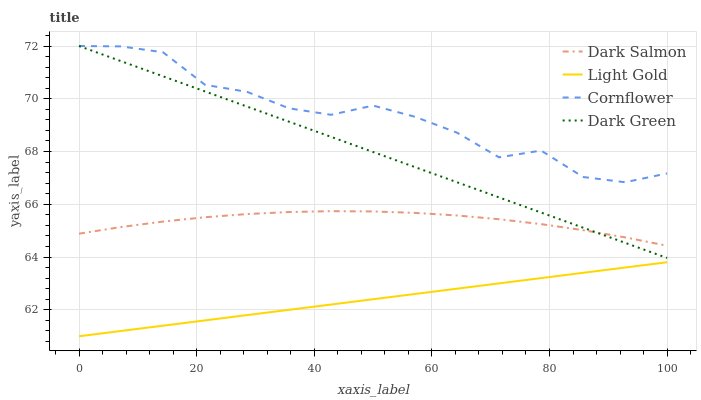Does Light Gold have the minimum area under the curve?
Answer yes or no. Yes. Does Cornflower have the maximum area under the curve?
Answer yes or no. Yes. Does Dark Salmon have the minimum area under the curve?
Answer yes or no. No. Does Dark Salmon have the maximum area under the curve?
Answer yes or no. No. Is Light Gold the smoothest?
Answer yes or no. Yes. Is Cornflower the roughest?
Answer yes or no. Yes. Is Dark Salmon the smoothest?
Answer yes or no. No. Is Dark Salmon the roughest?
Answer yes or no. No. Does Light Gold have the lowest value?
Answer yes or no. Yes. Does Dark Salmon have the lowest value?
Answer yes or no. No. Does Dark Green have the highest value?
Answer yes or no. Yes. Does Dark Salmon have the highest value?
Answer yes or no. No. Is Light Gold less than Cornflower?
Answer yes or no. Yes. Is Cornflower greater than Light Gold?
Answer yes or no. Yes. Does Dark Green intersect Dark Salmon?
Answer yes or no. Yes. Is Dark Green less than Dark Salmon?
Answer yes or no. No. Is Dark Green greater than Dark Salmon?
Answer yes or no. No. Does Light Gold intersect Cornflower?
Answer yes or no. No. 